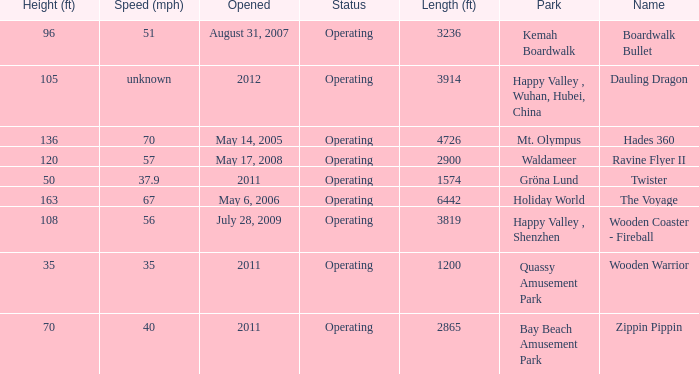At which park can boardwalk bullet be found? Kemah Boardwalk. 